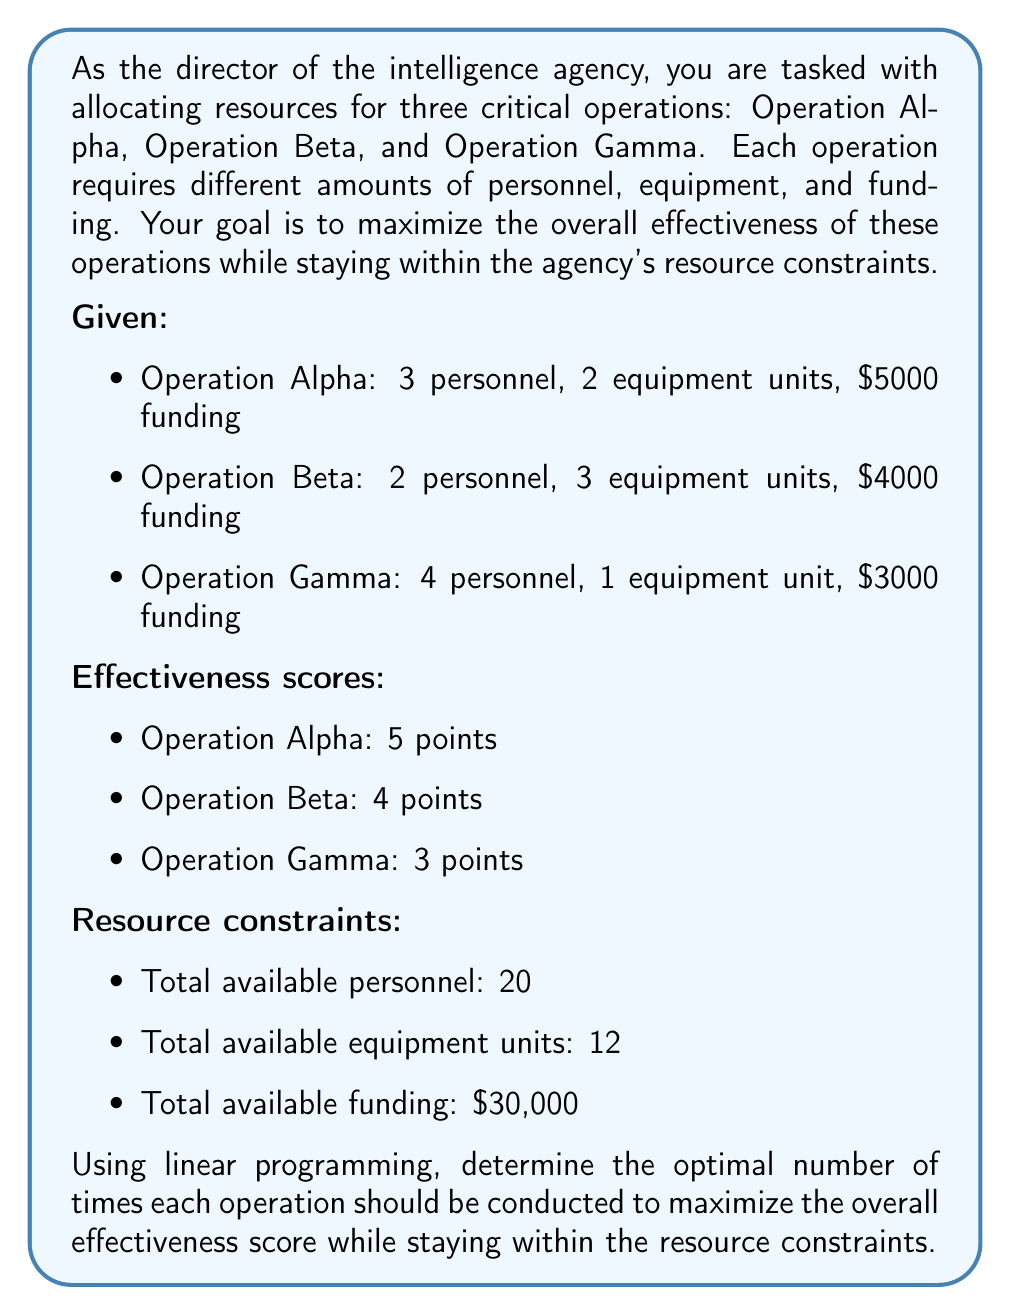Could you help me with this problem? To solve this problem using linear programming, we need to follow these steps:

1. Define the decision variables:
   Let $x$, $y$, and $z$ be the number of times Operations Alpha, Beta, and Gamma are conducted, respectively.

2. Set up the objective function:
   Maximize: $5x + 4y + 3z$

3. Define the constraints:
   a) Personnel constraint: $3x + 2y + 4z \leq 20$
   b) Equipment constraint: $2x + 3y + z \leq 12$
   c) Funding constraint: $5000x + 4000y + 3000z \leq 30000$
   d) Non-negativity constraints: $x, y, z \geq 0$

4. Solve the linear programming problem:

   We can use the simplex method or a linear programming solver to find the optimal solution. However, for this explanation, we'll use the graphical method since we have only three variables.

   First, we'll convert the funding constraint to match the scale of other constraints:
   $5x + 4y + 3z \leq 30$

   Now, we'll solve the system of equations:

   $3x + 2y + 4z = 20$
   $2x + 3y + z = 12$
   $5x + 4y + 3z = 30$

   Using substitution or elimination methods, we find the optimal solution:
   $x = 2$, $y = 2$, $z = 3$

5. Verify the solution:
   - Personnel: $3(2) + 2(2) + 4(3) = 20$ (meets constraint)
   - Equipment: $2(2) + 3(2) + 1(3) = 13$ (meets constraint)
   - Funding: $5000(2) + 4000(2) + 3000(3) = 29000$ (meets constraint)

6. Calculate the maximum effectiveness score:
   $5(2) + 4(2) + 3(3) = 19$

Therefore, the optimal allocation is to conduct Operation Alpha 2 times, Operation Beta 2 times, and Operation Gamma 3 times, resulting in a maximum effectiveness score of 19.
Answer: The optimal allocation is:
Operation Alpha: 2 times
Operation Beta: 2 times
Operation Gamma: 3 times
Maximum effectiveness score: 19 